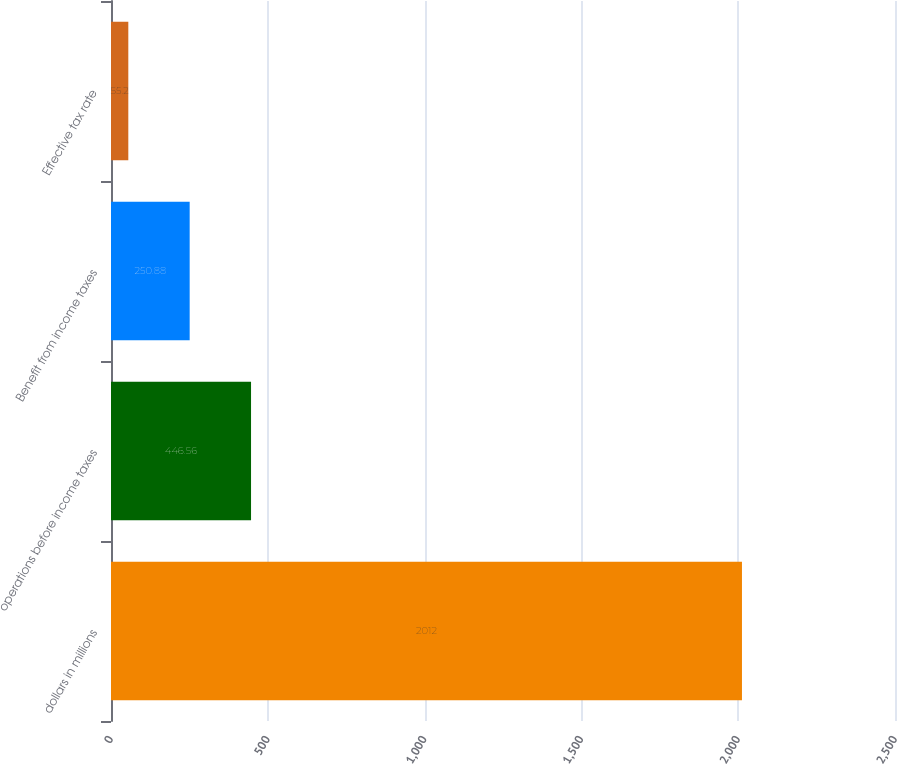Convert chart to OTSL. <chart><loc_0><loc_0><loc_500><loc_500><bar_chart><fcel>dollars in millions<fcel>operations before income taxes<fcel>Benefit from income taxes<fcel>Effective tax rate<nl><fcel>2012<fcel>446.56<fcel>250.88<fcel>55.2<nl></chart> 